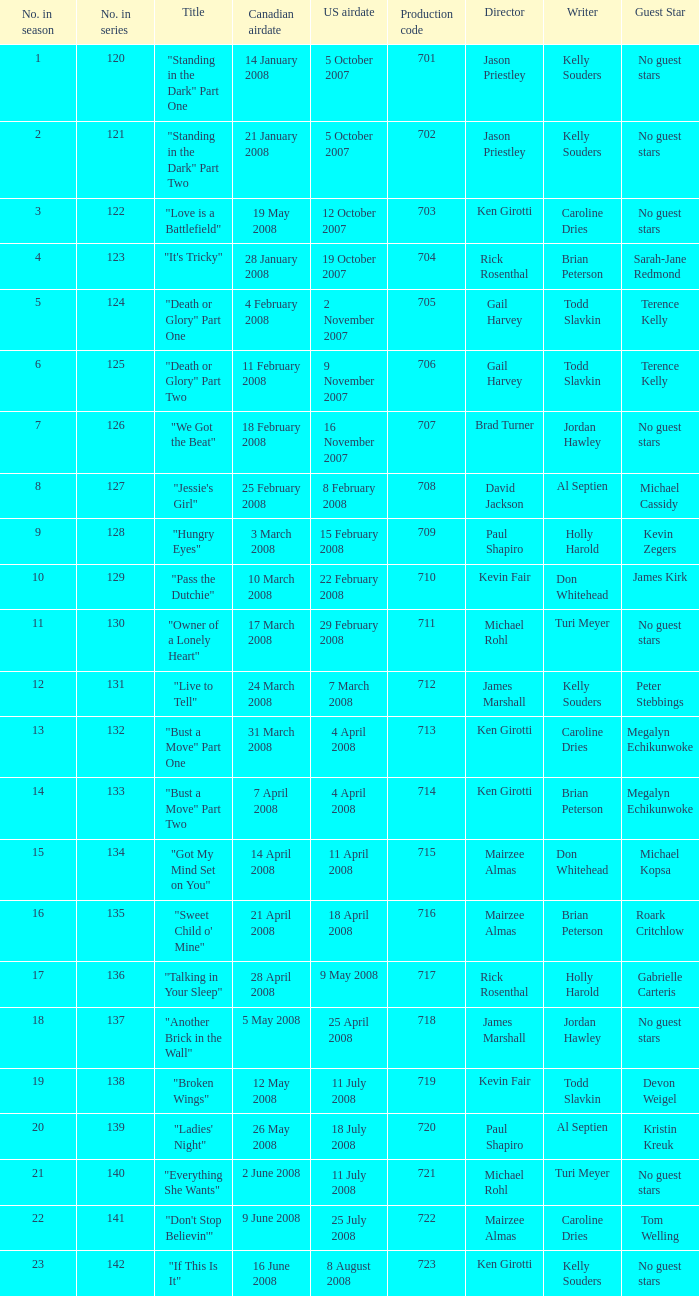For the episode(s) aired in the U.S. on 4 april 2008, what were the names? "Bust a Move" Part One, "Bust a Move" Part Two. 